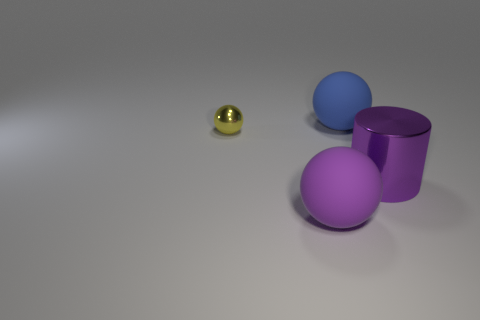Subtract all metallic balls. How many balls are left? 2 Add 2 tiny yellow metallic things. How many objects exist? 6 Subtract 1 balls. How many balls are left? 2 Subtract all yellow balls. How many balls are left? 2 Subtract all green cylinders. Subtract all brown balls. How many cylinders are left? 1 Subtract all purple spheres. How many blue cylinders are left? 0 Subtract all big gray rubber objects. Subtract all blue balls. How many objects are left? 3 Add 1 large purple metallic cylinders. How many large purple metallic cylinders are left? 2 Add 4 large metal cylinders. How many large metal cylinders exist? 5 Subtract 0 gray blocks. How many objects are left? 4 